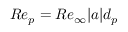Convert formula to latex. <formula><loc_0><loc_0><loc_500><loc_500>R e _ { p } = R e _ { \infty } | a | d _ { p }</formula> 